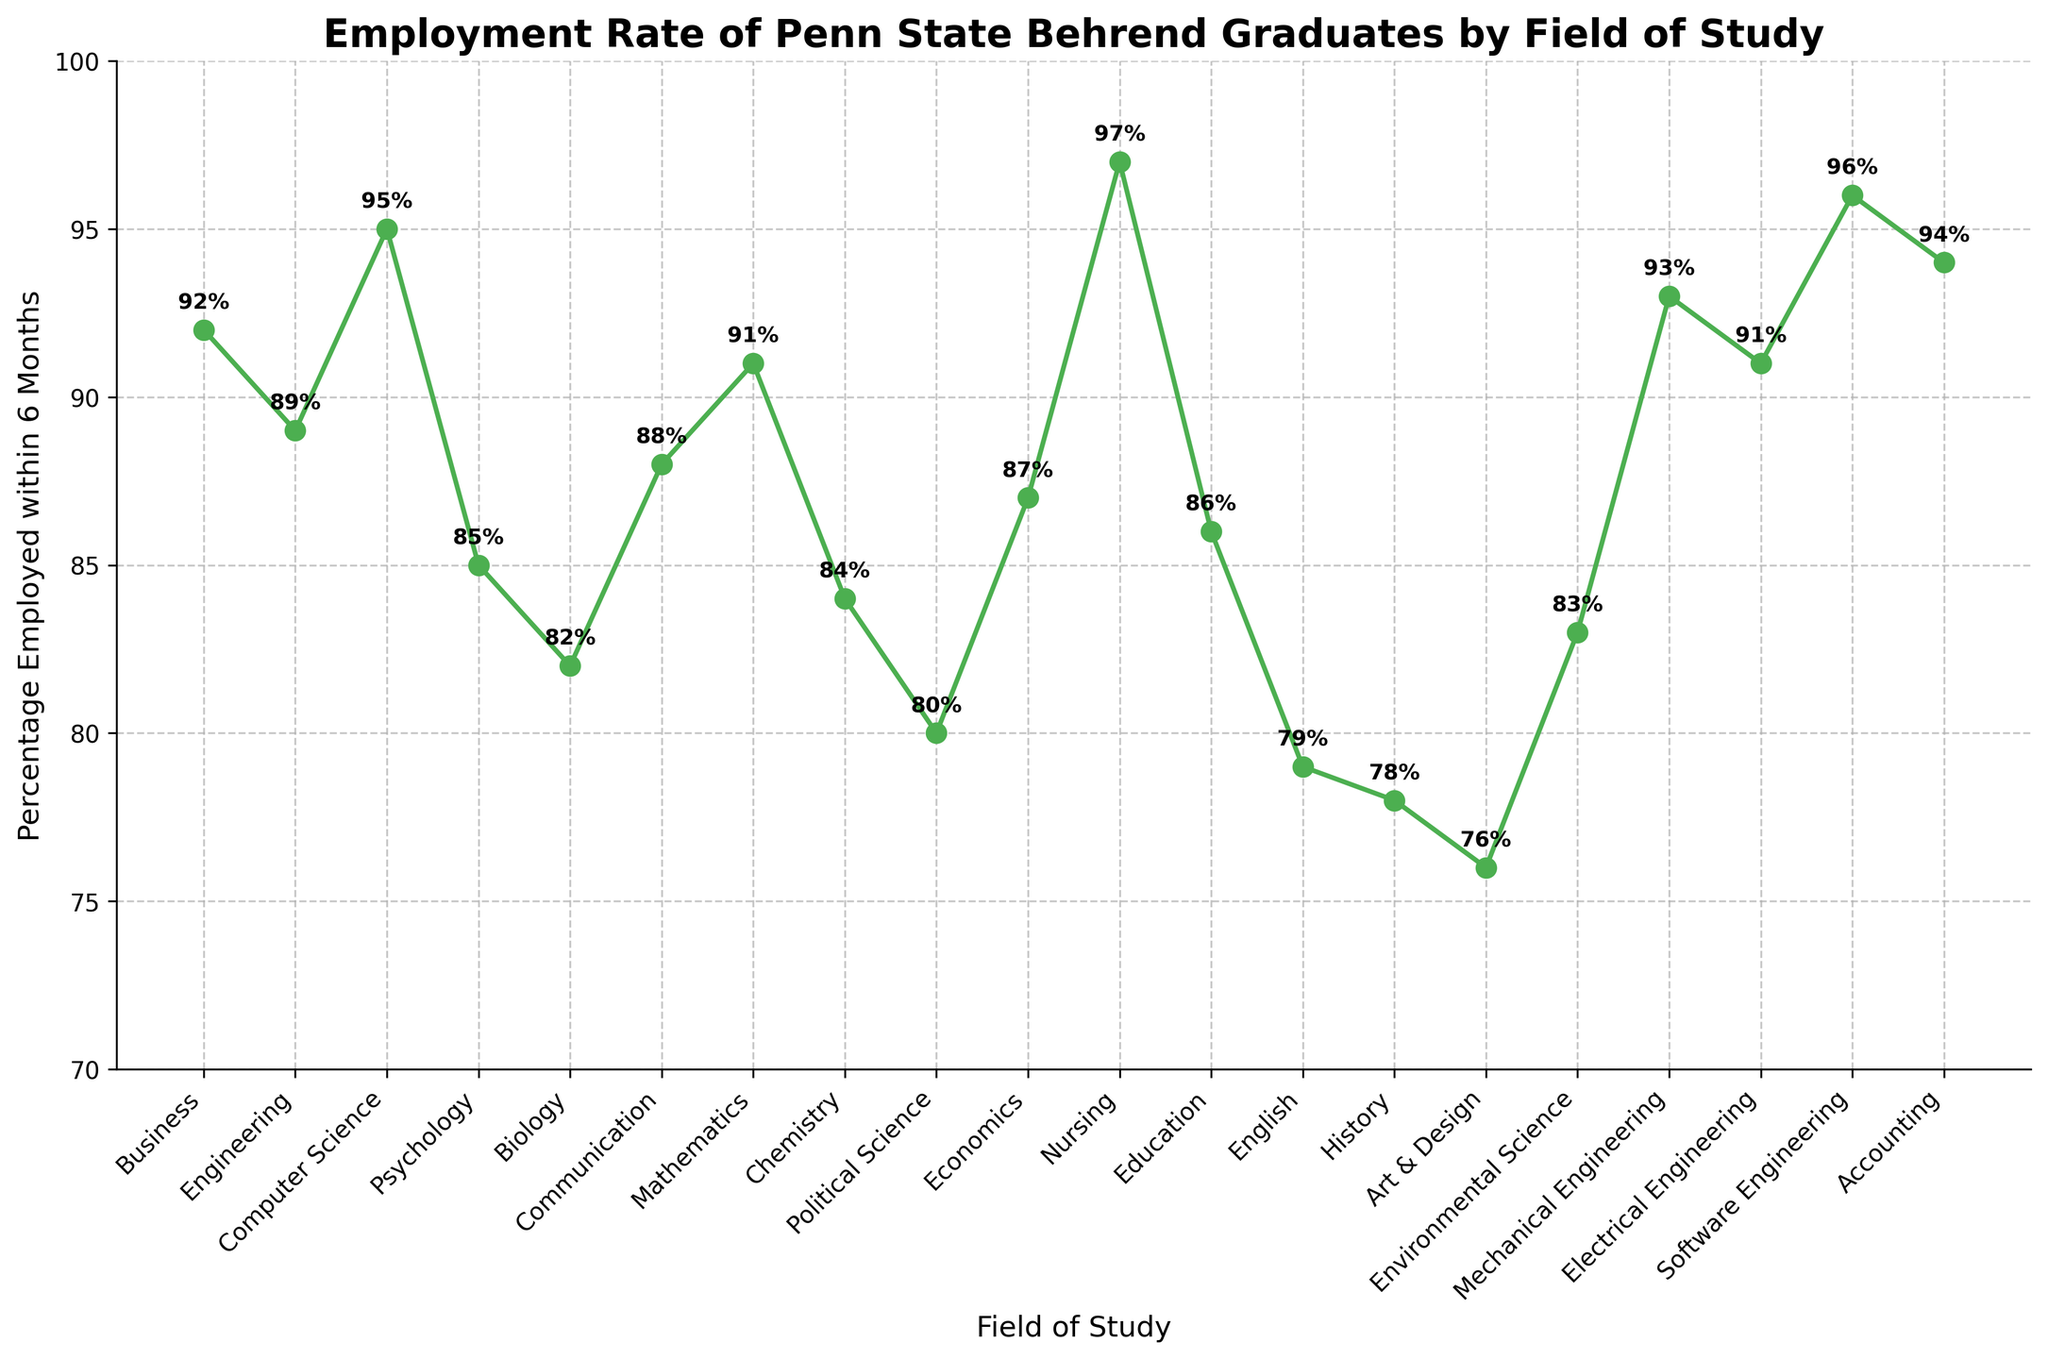What is the overall trend in the employment percentage across different fields? The figure shows that most fields have a high employment percentage above 80%, with a few lower exceptions. Generally, fields like Nursing, Software Engineering, and Computer Science have the highest percentages.
Answer: High, with a few exceptions Which field has the highest employment rate? The highest point on the plot corresponds to the field with the highest employment rate. By looking at the highest marker, we can see that Nursing has the highest employment percentage.
Answer: Nursing Which field has the lowest employment percentage? The lowest point on the plot corresponds to the field with the lowest employment rate. By identifying the lowest marker, we see that Art & Design has the lowest employment percentage.
Answer: Art & Design What is the average employment percentage across all fields? To calculate the average, sum all the employment percentages and divide by the number of fields. The sum is 1717, and there are 19 fields, so 1717/19.
Answer: ~90.37% How does the employment rate in Engineering (average of different Engineering disciplines) compare to the overall average? First, compute the average for the Engineering fields (89 for Engineering, 93 for Mechanical Engineering, and 91 for Electrical Engineering). Then compare it to the overall average of 90.37%. The average for Engineering fields is (89 + 93 + 91)/3 = 91.
Answer: Engineering fields have a higher average What is the employment variance across different fields of study? Calculate the variance by finding the mean, subtracting each percentage by the mean, squaring the results, summing up these squared differences, and dividing by the number of fields. Variance formula: Σ(P_i - μ)^2 / N, where P_i are employment percentages and μ is the mean. Numerical steps not shown for brevity.
Answer: ~31.81 Which fields have employment percentages greater than 90%? Identify all the markers that are above the 90% line. Fields such as Business, Computer Science, Mathematics, Mechanical Engineering, Electrical Engineering, Software Engineering, Accounting, and Nursing have percentages greater than 90%.
Answer: Business, Computer Science, Mathematics, Mechanical Engineering, Electrical Engineering, Software Engineering, Accounting, Nursing By how much does the employment percentage of Software Engineering exceed that of Psychology? Subtract the employment percentage of Psychology from that of Software Engineering (96% - 85%).
Answer: 11% Among Business, Economics, and Education, which has the highest employment rate? By comparing the markers for these fields, Business has 92%, Economics has 87%, and Education has 86%.
Answer: Business What is the difference in employment rate between the field with the highest percentage and the field with the lowest percentage? Subtract the lowest percentage (Art & Design, 76%) from the highest percentage (Nursing, 97%).
Answer: 21% 